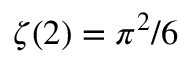Convert formula to latex. <formula><loc_0><loc_0><loc_500><loc_500>\zeta ( 2 ) = \pi ^ { 2 } / 6</formula> 